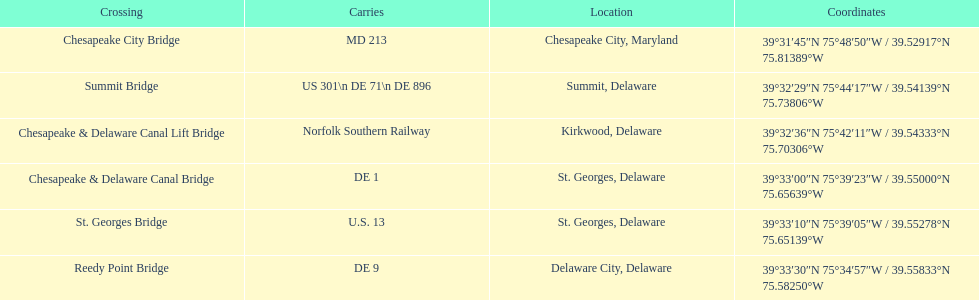Which bridge has their location in summit, delaware? Summit Bridge. 